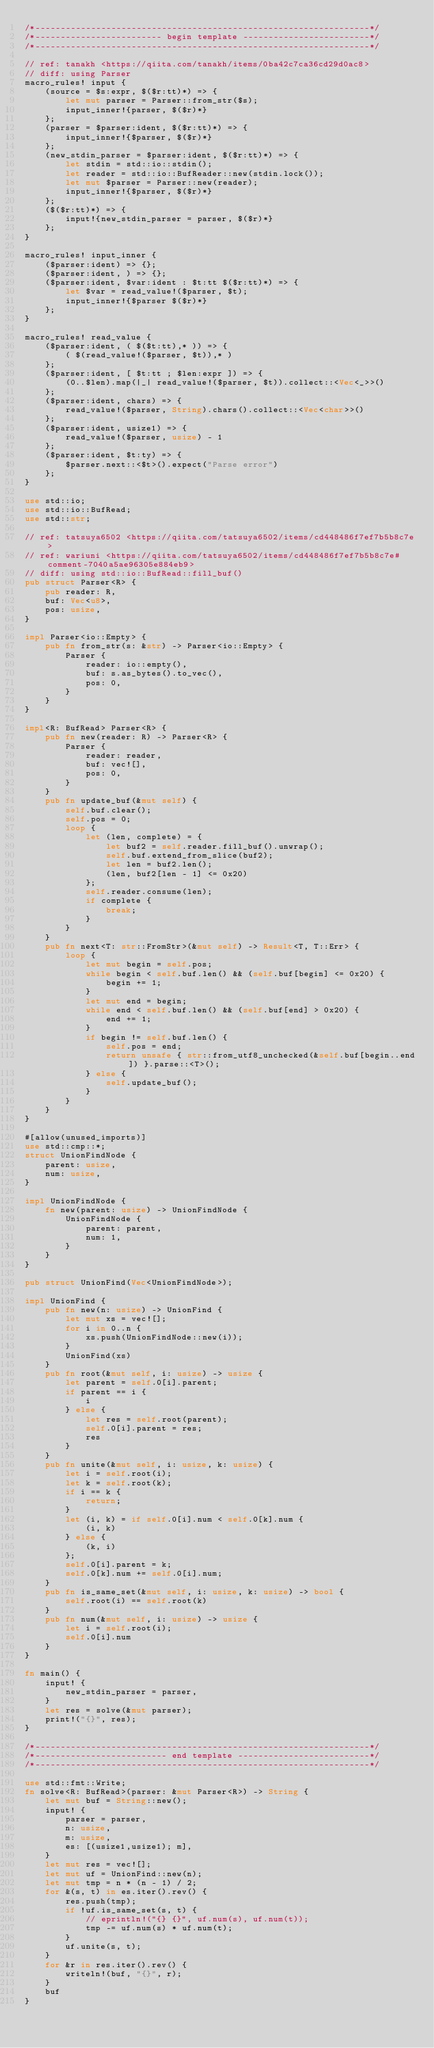Convert code to text. <code><loc_0><loc_0><loc_500><loc_500><_Rust_>/*------------------------------------------------------------------*/
/*------------------------- begin template -------------------------*/
/*------------------------------------------------------------------*/

// ref: tanakh <https://qiita.com/tanakh/items/0ba42c7ca36cd29d0ac8>
// diff: using Parser
macro_rules! input {
    (source = $s:expr, $($r:tt)*) => {
        let mut parser = Parser::from_str($s);
        input_inner!{parser, $($r)*}
    };
    (parser = $parser:ident, $($r:tt)*) => {
        input_inner!{$parser, $($r)*}
    };
    (new_stdin_parser = $parser:ident, $($r:tt)*) => {
        let stdin = std::io::stdin();
        let reader = std::io::BufReader::new(stdin.lock());
        let mut $parser = Parser::new(reader);
        input_inner!{$parser, $($r)*}
    };
    ($($r:tt)*) => {
        input!{new_stdin_parser = parser, $($r)*}
    };
}

macro_rules! input_inner {
    ($parser:ident) => {};
    ($parser:ident, ) => {};
    ($parser:ident, $var:ident : $t:tt $($r:tt)*) => {
        let $var = read_value!($parser, $t);
        input_inner!{$parser $($r)*}
    };
}

macro_rules! read_value {
    ($parser:ident, ( $($t:tt),* )) => {
        ( $(read_value!($parser, $t)),* )
    };
    ($parser:ident, [ $t:tt ; $len:expr ]) => {
        (0..$len).map(|_| read_value!($parser, $t)).collect::<Vec<_>>()
    };
    ($parser:ident, chars) => {
        read_value!($parser, String).chars().collect::<Vec<char>>()
    };
    ($parser:ident, usize1) => {
        read_value!($parser, usize) - 1
    };
    ($parser:ident, $t:ty) => {
        $parser.next::<$t>().expect("Parse error")
    };
}

use std::io;
use std::io::BufRead;
use std::str;

// ref: tatsuya6502 <https://qiita.com/tatsuya6502/items/cd448486f7ef7b5b8c7e>
// ref: wariuni <https://qiita.com/tatsuya6502/items/cd448486f7ef7b5b8c7e#comment-7040a5ae96305e884eb9>
// diff: using std::io::BufRead::fill_buf()
pub struct Parser<R> {
    pub reader: R,
    buf: Vec<u8>,
    pos: usize,
}

impl Parser<io::Empty> {
    pub fn from_str(s: &str) -> Parser<io::Empty> {
        Parser {
            reader: io::empty(),
            buf: s.as_bytes().to_vec(),
            pos: 0,
        }
    }
}

impl<R: BufRead> Parser<R> {
    pub fn new(reader: R) -> Parser<R> {
        Parser {
            reader: reader,
            buf: vec![],
            pos: 0,
        }
    }
    pub fn update_buf(&mut self) {
        self.buf.clear();
        self.pos = 0;
        loop {
            let (len, complete) = {
                let buf2 = self.reader.fill_buf().unwrap();
                self.buf.extend_from_slice(buf2);
                let len = buf2.len();
                (len, buf2[len - 1] <= 0x20)
            };
            self.reader.consume(len);
            if complete {
                break;
            }
        }
    }
    pub fn next<T: str::FromStr>(&mut self) -> Result<T, T::Err> {
        loop {
            let mut begin = self.pos;
            while begin < self.buf.len() && (self.buf[begin] <= 0x20) {
                begin += 1;
            }
            let mut end = begin;
            while end < self.buf.len() && (self.buf[end] > 0x20) {
                end += 1;
            }
            if begin != self.buf.len() {
                self.pos = end;
                return unsafe { str::from_utf8_unchecked(&self.buf[begin..end]) }.parse::<T>();
            } else {
                self.update_buf();
            }
        }
    }
}

#[allow(unused_imports)]
use std::cmp::*;
struct UnionFindNode {
    parent: usize,
    num: usize,
}

impl UnionFindNode {
    fn new(parent: usize) -> UnionFindNode {
        UnionFindNode {
            parent: parent,
            num: 1,
        }
    }
}

pub struct UnionFind(Vec<UnionFindNode>);

impl UnionFind {
    pub fn new(n: usize) -> UnionFind {
        let mut xs = vec![];
        for i in 0..n {
            xs.push(UnionFindNode::new(i));
        }
        UnionFind(xs)
    }
    pub fn root(&mut self, i: usize) -> usize {
        let parent = self.0[i].parent;
        if parent == i {
            i
        } else {
            let res = self.root(parent);
            self.0[i].parent = res;
            res
        }
    }
    pub fn unite(&mut self, i: usize, k: usize) {
        let i = self.root(i);
        let k = self.root(k);
        if i == k {
            return;
        }
        let (i, k) = if self.0[i].num < self.0[k].num {
            (i, k)
        } else {
            (k, i)
        };
        self.0[i].parent = k;
        self.0[k].num += self.0[i].num;
    }
    pub fn is_same_set(&mut self, i: usize, k: usize) -> bool {
        self.root(i) == self.root(k)
    }
    pub fn num(&mut self, i: usize) -> usize {
        let i = self.root(i);
        self.0[i].num
    }
}

fn main() {
    input! {
        new_stdin_parser = parser,
    }
    let res = solve(&mut parser);
    print!("{}", res);
}

/*------------------------------------------------------------------*/
/*-------------------------- end template --------------------------*/
/*------------------------------------------------------------------*/

use std::fmt::Write;
fn solve<R: BufRead>(parser: &mut Parser<R>) -> String {
    let mut buf = String::new();
    input! {
        parser = parser,
        n: usize,
        m: usize,
        es: [(usize1,usize1); m],
    }
    let mut res = vec![];
    let mut uf = UnionFind::new(n);
    let mut tmp = n * (n - 1) / 2;
    for &(s, t) in es.iter().rev() {
        res.push(tmp);
        if !uf.is_same_set(s, t) {
            // eprintln!("{} {}", uf.num(s), uf.num(t));
            tmp -= uf.num(s) * uf.num(t);
        }
        uf.unite(s, t);
    }
    for &r in res.iter().rev() {
        writeln!(buf, "{}", r);
    }
    buf
}
</code> 